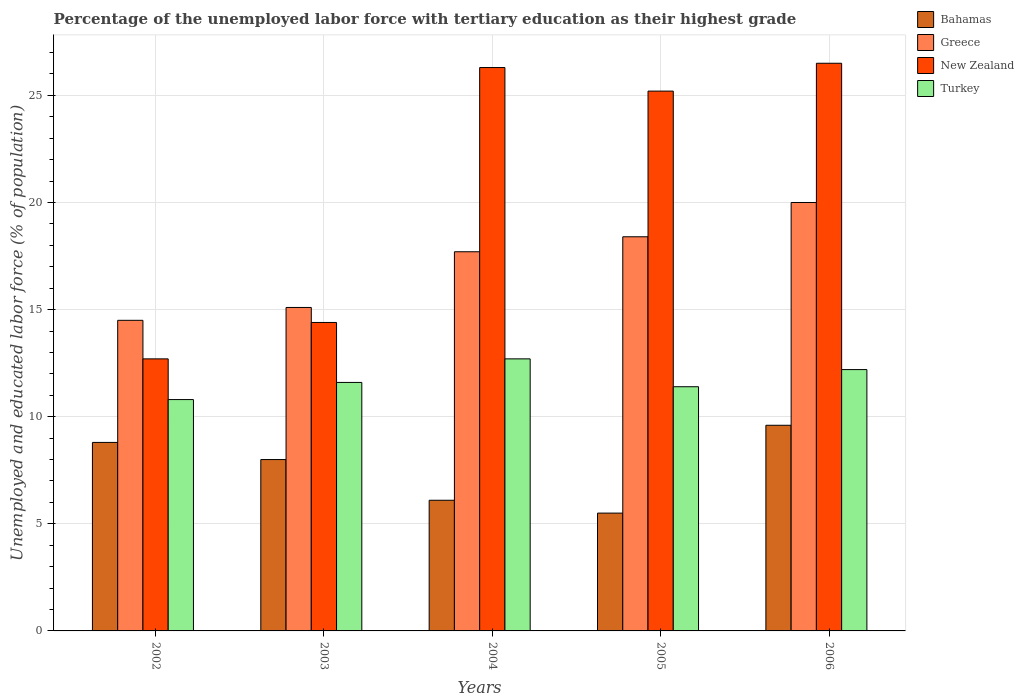How many groups of bars are there?
Give a very brief answer. 5. Are the number of bars on each tick of the X-axis equal?
Your response must be concise. Yes. How many bars are there on the 2nd tick from the left?
Give a very brief answer. 4. In how many cases, is the number of bars for a given year not equal to the number of legend labels?
Ensure brevity in your answer.  0. What is the percentage of the unemployed labor force with tertiary education in Greece in 2005?
Make the answer very short. 18.4. Across all years, what is the maximum percentage of the unemployed labor force with tertiary education in Turkey?
Provide a succinct answer. 12.7. Across all years, what is the minimum percentage of the unemployed labor force with tertiary education in New Zealand?
Your response must be concise. 12.7. In which year was the percentage of the unemployed labor force with tertiary education in New Zealand minimum?
Make the answer very short. 2002. What is the total percentage of the unemployed labor force with tertiary education in Bahamas in the graph?
Offer a terse response. 38. What is the difference between the percentage of the unemployed labor force with tertiary education in Greece in 2003 and that in 2004?
Your answer should be very brief. -2.6. What is the difference between the percentage of the unemployed labor force with tertiary education in Turkey in 2003 and the percentage of the unemployed labor force with tertiary education in New Zealand in 2002?
Give a very brief answer. -1.1. What is the average percentage of the unemployed labor force with tertiary education in Greece per year?
Keep it short and to the point. 17.14. In the year 2002, what is the difference between the percentage of the unemployed labor force with tertiary education in New Zealand and percentage of the unemployed labor force with tertiary education in Turkey?
Your answer should be very brief. 1.9. What is the ratio of the percentage of the unemployed labor force with tertiary education in New Zealand in 2004 to that in 2006?
Your answer should be very brief. 0.99. Is the difference between the percentage of the unemployed labor force with tertiary education in New Zealand in 2004 and 2005 greater than the difference between the percentage of the unemployed labor force with tertiary education in Turkey in 2004 and 2005?
Ensure brevity in your answer.  No. What is the difference between the highest and the second highest percentage of the unemployed labor force with tertiary education in Turkey?
Your answer should be compact. 0.5. In how many years, is the percentage of the unemployed labor force with tertiary education in Greece greater than the average percentage of the unemployed labor force with tertiary education in Greece taken over all years?
Offer a very short reply. 3. Is the sum of the percentage of the unemployed labor force with tertiary education in Turkey in 2003 and 2005 greater than the maximum percentage of the unemployed labor force with tertiary education in Bahamas across all years?
Your response must be concise. Yes. Is it the case that in every year, the sum of the percentage of the unemployed labor force with tertiary education in Bahamas and percentage of the unemployed labor force with tertiary education in Greece is greater than the sum of percentage of the unemployed labor force with tertiary education in Turkey and percentage of the unemployed labor force with tertiary education in New Zealand?
Offer a very short reply. No. What does the 3rd bar from the left in 2004 represents?
Offer a terse response. New Zealand. What does the 3rd bar from the right in 2004 represents?
Ensure brevity in your answer.  Greece. Are all the bars in the graph horizontal?
Provide a short and direct response. No. Are the values on the major ticks of Y-axis written in scientific E-notation?
Ensure brevity in your answer.  No. Does the graph contain any zero values?
Ensure brevity in your answer.  No. Does the graph contain grids?
Offer a terse response. Yes. How many legend labels are there?
Your response must be concise. 4. How are the legend labels stacked?
Make the answer very short. Vertical. What is the title of the graph?
Give a very brief answer. Percentage of the unemployed labor force with tertiary education as their highest grade. What is the label or title of the Y-axis?
Provide a succinct answer. Unemployed and educated labor force (% of population). What is the Unemployed and educated labor force (% of population) of Bahamas in 2002?
Keep it short and to the point. 8.8. What is the Unemployed and educated labor force (% of population) of New Zealand in 2002?
Your answer should be very brief. 12.7. What is the Unemployed and educated labor force (% of population) of Turkey in 2002?
Offer a terse response. 10.8. What is the Unemployed and educated labor force (% of population) in Bahamas in 2003?
Ensure brevity in your answer.  8. What is the Unemployed and educated labor force (% of population) of Greece in 2003?
Provide a succinct answer. 15.1. What is the Unemployed and educated labor force (% of population) in New Zealand in 2003?
Your answer should be compact. 14.4. What is the Unemployed and educated labor force (% of population) in Turkey in 2003?
Your answer should be very brief. 11.6. What is the Unemployed and educated labor force (% of population) of Bahamas in 2004?
Provide a short and direct response. 6.1. What is the Unemployed and educated labor force (% of population) of Greece in 2004?
Your answer should be very brief. 17.7. What is the Unemployed and educated labor force (% of population) in New Zealand in 2004?
Offer a terse response. 26.3. What is the Unemployed and educated labor force (% of population) in Turkey in 2004?
Ensure brevity in your answer.  12.7. What is the Unemployed and educated labor force (% of population) in Greece in 2005?
Your response must be concise. 18.4. What is the Unemployed and educated labor force (% of population) of New Zealand in 2005?
Provide a succinct answer. 25.2. What is the Unemployed and educated labor force (% of population) in Turkey in 2005?
Provide a succinct answer. 11.4. What is the Unemployed and educated labor force (% of population) of Bahamas in 2006?
Your answer should be very brief. 9.6. What is the Unemployed and educated labor force (% of population) of Greece in 2006?
Offer a very short reply. 20. What is the Unemployed and educated labor force (% of population) in New Zealand in 2006?
Give a very brief answer. 26.5. What is the Unemployed and educated labor force (% of population) in Turkey in 2006?
Your answer should be compact. 12.2. Across all years, what is the maximum Unemployed and educated labor force (% of population) of Bahamas?
Provide a succinct answer. 9.6. Across all years, what is the maximum Unemployed and educated labor force (% of population) in Greece?
Your answer should be very brief. 20. Across all years, what is the maximum Unemployed and educated labor force (% of population) of Turkey?
Your answer should be very brief. 12.7. Across all years, what is the minimum Unemployed and educated labor force (% of population) of Bahamas?
Your answer should be compact. 5.5. Across all years, what is the minimum Unemployed and educated labor force (% of population) of New Zealand?
Keep it short and to the point. 12.7. Across all years, what is the minimum Unemployed and educated labor force (% of population) in Turkey?
Offer a terse response. 10.8. What is the total Unemployed and educated labor force (% of population) in Greece in the graph?
Offer a terse response. 85.7. What is the total Unemployed and educated labor force (% of population) in New Zealand in the graph?
Provide a short and direct response. 105.1. What is the total Unemployed and educated labor force (% of population) in Turkey in the graph?
Offer a terse response. 58.7. What is the difference between the Unemployed and educated labor force (% of population) in Greece in 2002 and that in 2003?
Provide a short and direct response. -0.6. What is the difference between the Unemployed and educated labor force (% of population) in Turkey in 2002 and that in 2003?
Provide a succinct answer. -0.8. What is the difference between the Unemployed and educated labor force (% of population) of New Zealand in 2002 and that in 2004?
Offer a terse response. -13.6. What is the difference between the Unemployed and educated labor force (% of population) in Turkey in 2002 and that in 2004?
Offer a very short reply. -1.9. What is the difference between the Unemployed and educated labor force (% of population) in Greece in 2002 and that in 2005?
Keep it short and to the point. -3.9. What is the difference between the Unemployed and educated labor force (% of population) of New Zealand in 2002 and that in 2005?
Ensure brevity in your answer.  -12.5. What is the difference between the Unemployed and educated labor force (% of population) of New Zealand in 2003 and that in 2004?
Your answer should be very brief. -11.9. What is the difference between the Unemployed and educated labor force (% of population) of Turkey in 2003 and that in 2004?
Keep it short and to the point. -1.1. What is the difference between the Unemployed and educated labor force (% of population) of New Zealand in 2003 and that in 2005?
Provide a succinct answer. -10.8. What is the difference between the Unemployed and educated labor force (% of population) in Bahamas in 2004 and that in 2005?
Give a very brief answer. 0.6. What is the difference between the Unemployed and educated labor force (% of population) in Greece in 2004 and that in 2005?
Make the answer very short. -0.7. What is the difference between the Unemployed and educated labor force (% of population) in Turkey in 2004 and that in 2005?
Keep it short and to the point. 1.3. What is the difference between the Unemployed and educated labor force (% of population) of Bahamas in 2004 and that in 2006?
Provide a short and direct response. -3.5. What is the difference between the Unemployed and educated labor force (% of population) of New Zealand in 2005 and that in 2006?
Your response must be concise. -1.3. What is the difference between the Unemployed and educated labor force (% of population) in Bahamas in 2002 and the Unemployed and educated labor force (% of population) in Greece in 2003?
Offer a very short reply. -6.3. What is the difference between the Unemployed and educated labor force (% of population) in Bahamas in 2002 and the Unemployed and educated labor force (% of population) in New Zealand in 2003?
Offer a very short reply. -5.6. What is the difference between the Unemployed and educated labor force (% of population) of Greece in 2002 and the Unemployed and educated labor force (% of population) of New Zealand in 2003?
Make the answer very short. 0.1. What is the difference between the Unemployed and educated labor force (% of population) of Greece in 2002 and the Unemployed and educated labor force (% of population) of Turkey in 2003?
Offer a terse response. 2.9. What is the difference between the Unemployed and educated labor force (% of population) in Bahamas in 2002 and the Unemployed and educated labor force (% of population) in Greece in 2004?
Provide a succinct answer. -8.9. What is the difference between the Unemployed and educated labor force (% of population) in Bahamas in 2002 and the Unemployed and educated labor force (% of population) in New Zealand in 2004?
Your answer should be very brief. -17.5. What is the difference between the Unemployed and educated labor force (% of population) of New Zealand in 2002 and the Unemployed and educated labor force (% of population) of Turkey in 2004?
Provide a succinct answer. 0. What is the difference between the Unemployed and educated labor force (% of population) of Bahamas in 2002 and the Unemployed and educated labor force (% of population) of New Zealand in 2005?
Provide a succinct answer. -16.4. What is the difference between the Unemployed and educated labor force (% of population) of Greece in 2002 and the Unemployed and educated labor force (% of population) of Turkey in 2005?
Your response must be concise. 3.1. What is the difference between the Unemployed and educated labor force (% of population) in Bahamas in 2002 and the Unemployed and educated labor force (% of population) in Greece in 2006?
Provide a succinct answer. -11.2. What is the difference between the Unemployed and educated labor force (% of population) in Bahamas in 2002 and the Unemployed and educated labor force (% of population) in New Zealand in 2006?
Your answer should be compact. -17.7. What is the difference between the Unemployed and educated labor force (% of population) in Bahamas in 2002 and the Unemployed and educated labor force (% of population) in Turkey in 2006?
Give a very brief answer. -3.4. What is the difference between the Unemployed and educated labor force (% of population) of Greece in 2002 and the Unemployed and educated labor force (% of population) of New Zealand in 2006?
Provide a short and direct response. -12. What is the difference between the Unemployed and educated labor force (% of population) of Greece in 2002 and the Unemployed and educated labor force (% of population) of Turkey in 2006?
Give a very brief answer. 2.3. What is the difference between the Unemployed and educated labor force (% of population) of Bahamas in 2003 and the Unemployed and educated labor force (% of population) of Greece in 2004?
Give a very brief answer. -9.7. What is the difference between the Unemployed and educated labor force (% of population) of Bahamas in 2003 and the Unemployed and educated labor force (% of population) of New Zealand in 2004?
Your response must be concise. -18.3. What is the difference between the Unemployed and educated labor force (% of population) in Bahamas in 2003 and the Unemployed and educated labor force (% of population) in Turkey in 2004?
Your answer should be compact. -4.7. What is the difference between the Unemployed and educated labor force (% of population) in Greece in 2003 and the Unemployed and educated labor force (% of population) in New Zealand in 2004?
Keep it short and to the point. -11.2. What is the difference between the Unemployed and educated labor force (% of population) in Greece in 2003 and the Unemployed and educated labor force (% of population) in Turkey in 2004?
Ensure brevity in your answer.  2.4. What is the difference between the Unemployed and educated labor force (% of population) in Bahamas in 2003 and the Unemployed and educated labor force (% of population) in Greece in 2005?
Keep it short and to the point. -10.4. What is the difference between the Unemployed and educated labor force (% of population) in Bahamas in 2003 and the Unemployed and educated labor force (% of population) in New Zealand in 2005?
Your response must be concise. -17.2. What is the difference between the Unemployed and educated labor force (% of population) in Bahamas in 2003 and the Unemployed and educated labor force (% of population) in Turkey in 2005?
Make the answer very short. -3.4. What is the difference between the Unemployed and educated labor force (% of population) of Greece in 2003 and the Unemployed and educated labor force (% of population) of New Zealand in 2005?
Ensure brevity in your answer.  -10.1. What is the difference between the Unemployed and educated labor force (% of population) in Greece in 2003 and the Unemployed and educated labor force (% of population) in Turkey in 2005?
Make the answer very short. 3.7. What is the difference between the Unemployed and educated labor force (% of population) of Bahamas in 2003 and the Unemployed and educated labor force (% of population) of Greece in 2006?
Offer a terse response. -12. What is the difference between the Unemployed and educated labor force (% of population) of Bahamas in 2003 and the Unemployed and educated labor force (% of population) of New Zealand in 2006?
Your answer should be compact. -18.5. What is the difference between the Unemployed and educated labor force (% of population) in Bahamas in 2003 and the Unemployed and educated labor force (% of population) in Turkey in 2006?
Your answer should be compact. -4.2. What is the difference between the Unemployed and educated labor force (% of population) of Greece in 2003 and the Unemployed and educated labor force (% of population) of New Zealand in 2006?
Your answer should be compact. -11.4. What is the difference between the Unemployed and educated labor force (% of population) in Greece in 2003 and the Unemployed and educated labor force (% of population) in Turkey in 2006?
Your response must be concise. 2.9. What is the difference between the Unemployed and educated labor force (% of population) in Bahamas in 2004 and the Unemployed and educated labor force (% of population) in New Zealand in 2005?
Provide a succinct answer. -19.1. What is the difference between the Unemployed and educated labor force (% of population) of Bahamas in 2004 and the Unemployed and educated labor force (% of population) of New Zealand in 2006?
Offer a very short reply. -20.4. What is the difference between the Unemployed and educated labor force (% of population) in Greece in 2004 and the Unemployed and educated labor force (% of population) in Turkey in 2006?
Make the answer very short. 5.5. What is the difference between the Unemployed and educated labor force (% of population) of Greece in 2005 and the Unemployed and educated labor force (% of population) of Turkey in 2006?
Offer a terse response. 6.2. What is the average Unemployed and educated labor force (% of population) in Greece per year?
Give a very brief answer. 17.14. What is the average Unemployed and educated labor force (% of population) in New Zealand per year?
Provide a short and direct response. 21.02. What is the average Unemployed and educated labor force (% of population) in Turkey per year?
Ensure brevity in your answer.  11.74. In the year 2002, what is the difference between the Unemployed and educated labor force (% of population) in Bahamas and Unemployed and educated labor force (% of population) in Greece?
Keep it short and to the point. -5.7. In the year 2002, what is the difference between the Unemployed and educated labor force (% of population) of Bahamas and Unemployed and educated labor force (% of population) of New Zealand?
Offer a terse response. -3.9. In the year 2002, what is the difference between the Unemployed and educated labor force (% of population) of Bahamas and Unemployed and educated labor force (% of population) of Turkey?
Your answer should be compact. -2. In the year 2002, what is the difference between the Unemployed and educated labor force (% of population) of Greece and Unemployed and educated labor force (% of population) of New Zealand?
Provide a succinct answer. 1.8. In the year 2003, what is the difference between the Unemployed and educated labor force (% of population) of Bahamas and Unemployed and educated labor force (% of population) of Greece?
Offer a very short reply. -7.1. In the year 2003, what is the difference between the Unemployed and educated labor force (% of population) in Bahamas and Unemployed and educated labor force (% of population) in New Zealand?
Provide a succinct answer. -6.4. In the year 2003, what is the difference between the Unemployed and educated labor force (% of population) in Greece and Unemployed and educated labor force (% of population) in New Zealand?
Your response must be concise. 0.7. In the year 2003, what is the difference between the Unemployed and educated labor force (% of population) in Greece and Unemployed and educated labor force (% of population) in Turkey?
Offer a terse response. 3.5. In the year 2004, what is the difference between the Unemployed and educated labor force (% of population) of Bahamas and Unemployed and educated labor force (% of population) of Greece?
Your answer should be compact. -11.6. In the year 2004, what is the difference between the Unemployed and educated labor force (% of population) in Bahamas and Unemployed and educated labor force (% of population) in New Zealand?
Offer a very short reply. -20.2. In the year 2004, what is the difference between the Unemployed and educated labor force (% of population) of Bahamas and Unemployed and educated labor force (% of population) of Turkey?
Your answer should be compact. -6.6. In the year 2004, what is the difference between the Unemployed and educated labor force (% of population) of Greece and Unemployed and educated labor force (% of population) of New Zealand?
Give a very brief answer. -8.6. In the year 2005, what is the difference between the Unemployed and educated labor force (% of population) of Bahamas and Unemployed and educated labor force (% of population) of New Zealand?
Provide a short and direct response. -19.7. In the year 2005, what is the difference between the Unemployed and educated labor force (% of population) of Bahamas and Unemployed and educated labor force (% of population) of Turkey?
Your answer should be compact. -5.9. In the year 2005, what is the difference between the Unemployed and educated labor force (% of population) of Greece and Unemployed and educated labor force (% of population) of New Zealand?
Your answer should be compact. -6.8. In the year 2005, what is the difference between the Unemployed and educated labor force (% of population) in Greece and Unemployed and educated labor force (% of population) in Turkey?
Your answer should be compact. 7. In the year 2005, what is the difference between the Unemployed and educated labor force (% of population) of New Zealand and Unemployed and educated labor force (% of population) of Turkey?
Give a very brief answer. 13.8. In the year 2006, what is the difference between the Unemployed and educated labor force (% of population) in Bahamas and Unemployed and educated labor force (% of population) in New Zealand?
Provide a short and direct response. -16.9. In the year 2006, what is the difference between the Unemployed and educated labor force (% of population) of Bahamas and Unemployed and educated labor force (% of population) of Turkey?
Offer a terse response. -2.6. In the year 2006, what is the difference between the Unemployed and educated labor force (% of population) in Greece and Unemployed and educated labor force (% of population) in Turkey?
Your response must be concise. 7.8. What is the ratio of the Unemployed and educated labor force (% of population) of Greece in 2002 to that in 2003?
Offer a very short reply. 0.96. What is the ratio of the Unemployed and educated labor force (% of population) of New Zealand in 2002 to that in 2003?
Offer a terse response. 0.88. What is the ratio of the Unemployed and educated labor force (% of population) in Bahamas in 2002 to that in 2004?
Your answer should be very brief. 1.44. What is the ratio of the Unemployed and educated labor force (% of population) of Greece in 2002 to that in 2004?
Ensure brevity in your answer.  0.82. What is the ratio of the Unemployed and educated labor force (% of population) of New Zealand in 2002 to that in 2004?
Keep it short and to the point. 0.48. What is the ratio of the Unemployed and educated labor force (% of population) in Turkey in 2002 to that in 2004?
Your answer should be compact. 0.85. What is the ratio of the Unemployed and educated labor force (% of population) in Bahamas in 2002 to that in 2005?
Your answer should be very brief. 1.6. What is the ratio of the Unemployed and educated labor force (% of population) of Greece in 2002 to that in 2005?
Your response must be concise. 0.79. What is the ratio of the Unemployed and educated labor force (% of population) in New Zealand in 2002 to that in 2005?
Make the answer very short. 0.5. What is the ratio of the Unemployed and educated labor force (% of population) in Greece in 2002 to that in 2006?
Provide a succinct answer. 0.72. What is the ratio of the Unemployed and educated labor force (% of population) of New Zealand in 2002 to that in 2006?
Give a very brief answer. 0.48. What is the ratio of the Unemployed and educated labor force (% of population) of Turkey in 2002 to that in 2006?
Offer a very short reply. 0.89. What is the ratio of the Unemployed and educated labor force (% of population) of Bahamas in 2003 to that in 2004?
Provide a succinct answer. 1.31. What is the ratio of the Unemployed and educated labor force (% of population) of Greece in 2003 to that in 2004?
Ensure brevity in your answer.  0.85. What is the ratio of the Unemployed and educated labor force (% of population) in New Zealand in 2003 to that in 2004?
Keep it short and to the point. 0.55. What is the ratio of the Unemployed and educated labor force (% of population) in Turkey in 2003 to that in 2004?
Offer a terse response. 0.91. What is the ratio of the Unemployed and educated labor force (% of population) of Bahamas in 2003 to that in 2005?
Your response must be concise. 1.45. What is the ratio of the Unemployed and educated labor force (% of population) of Greece in 2003 to that in 2005?
Make the answer very short. 0.82. What is the ratio of the Unemployed and educated labor force (% of population) in Turkey in 2003 to that in 2005?
Provide a short and direct response. 1.02. What is the ratio of the Unemployed and educated labor force (% of population) in Bahamas in 2003 to that in 2006?
Provide a short and direct response. 0.83. What is the ratio of the Unemployed and educated labor force (% of population) of Greece in 2003 to that in 2006?
Offer a terse response. 0.76. What is the ratio of the Unemployed and educated labor force (% of population) in New Zealand in 2003 to that in 2006?
Make the answer very short. 0.54. What is the ratio of the Unemployed and educated labor force (% of population) in Turkey in 2003 to that in 2006?
Ensure brevity in your answer.  0.95. What is the ratio of the Unemployed and educated labor force (% of population) of Bahamas in 2004 to that in 2005?
Offer a very short reply. 1.11. What is the ratio of the Unemployed and educated labor force (% of population) of Greece in 2004 to that in 2005?
Give a very brief answer. 0.96. What is the ratio of the Unemployed and educated labor force (% of population) in New Zealand in 2004 to that in 2005?
Keep it short and to the point. 1.04. What is the ratio of the Unemployed and educated labor force (% of population) in Turkey in 2004 to that in 2005?
Provide a succinct answer. 1.11. What is the ratio of the Unemployed and educated labor force (% of population) in Bahamas in 2004 to that in 2006?
Your response must be concise. 0.64. What is the ratio of the Unemployed and educated labor force (% of population) of Greece in 2004 to that in 2006?
Your response must be concise. 0.89. What is the ratio of the Unemployed and educated labor force (% of population) in Turkey in 2004 to that in 2006?
Your response must be concise. 1.04. What is the ratio of the Unemployed and educated labor force (% of population) in Bahamas in 2005 to that in 2006?
Your response must be concise. 0.57. What is the ratio of the Unemployed and educated labor force (% of population) in Greece in 2005 to that in 2006?
Keep it short and to the point. 0.92. What is the ratio of the Unemployed and educated labor force (% of population) of New Zealand in 2005 to that in 2006?
Offer a terse response. 0.95. What is the ratio of the Unemployed and educated labor force (% of population) of Turkey in 2005 to that in 2006?
Give a very brief answer. 0.93. What is the difference between the highest and the second highest Unemployed and educated labor force (% of population) in Greece?
Offer a terse response. 1.6. What is the difference between the highest and the second highest Unemployed and educated labor force (% of population) of New Zealand?
Ensure brevity in your answer.  0.2. What is the difference between the highest and the second highest Unemployed and educated labor force (% of population) in Turkey?
Keep it short and to the point. 0.5. What is the difference between the highest and the lowest Unemployed and educated labor force (% of population) of Bahamas?
Provide a short and direct response. 4.1. What is the difference between the highest and the lowest Unemployed and educated labor force (% of population) of Greece?
Your answer should be very brief. 5.5. What is the difference between the highest and the lowest Unemployed and educated labor force (% of population) of New Zealand?
Provide a succinct answer. 13.8. What is the difference between the highest and the lowest Unemployed and educated labor force (% of population) in Turkey?
Offer a terse response. 1.9. 